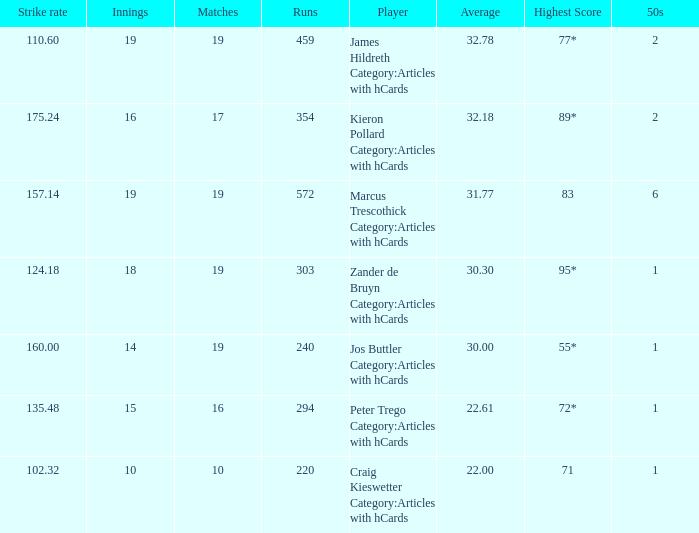What is the strike rate for the player with an average of 32.78? 110.6. 